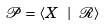<formula> <loc_0><loc_0><loc_500><loc_500>\mathcal { P } = \langle X \ | \ \mathcal { R } \rangle</formula> 